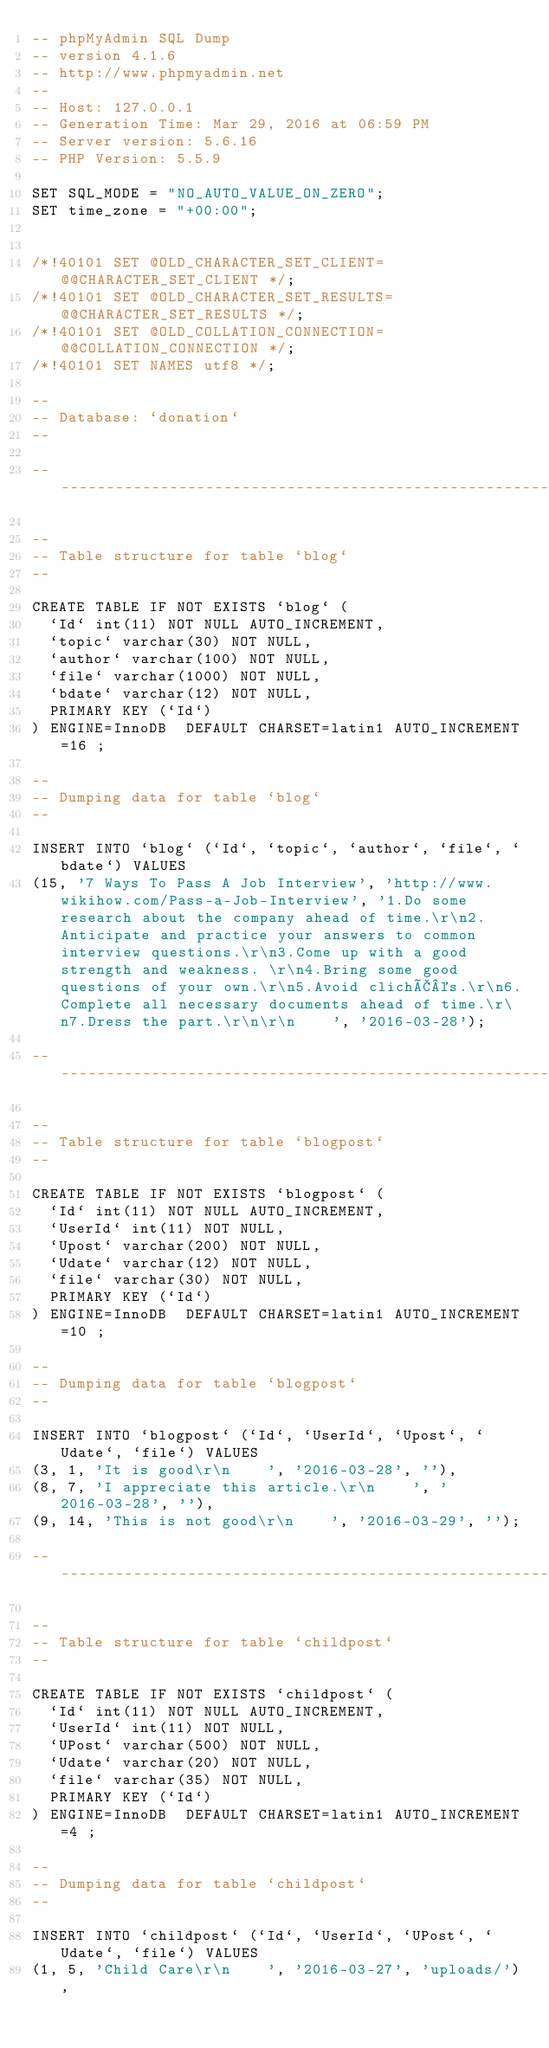<code> <loc_0><loc_0><loc_500><loc_500><_SQL_>-- phpMyAdmin SQL Dump
-- version 4.1.6
-- http://www.phpmyadmin.net
--
-- Host: 127.0.0.1
-- Generation Time: Mar 29, 2016 at 06:59 PM
-- Server version: 5.6.16
-- PHP Version: 5.5.9

SET SQL_MODE = "NO_AUTO_VALUE_ON_ZERO";
SET time_zone = "+00:00";


/*!40101 SET @OLD_CHARACTER_SET_CLIENT=@@CHARACTER_SET_CLIENT */;
/*!40101 SET @OLD_CHARACTER_SET_RESULTS=@@CHARACTER_SET_RESULTS */;
/*!40101 SET @OLD_COLLATION_CONNECTION=@@COLLATION_CONNECTION */;
/*!40101 SET NAMES utf8 */;

--
-- Database: `donation`
--

-- --------------------------------------------------------

--
-- Table structure for table `blog`
--

CREATE TABLE IF NOT EXISTS `blog` (
  `Id` int(11) NOT NULL AUTO_INCREMENT,
  `topic` varchar(30) NOT NULL,
  `author` varchar(100) NOT NULL,
  `file` varchar(1000) NOT NULL,
  `bdate` varchar(12) NOT NULL,
  PRIMARY KEY (`Id`)
) ENGINE=InnoDB  DEFAULT CHARSET=latin1 AUTO_INCREMENT=16 ;

--
-- Dumping data for table `blog`
--

INSERT INTO `blog` (`Id`, `topic`, `author`, `file`, `bdate`) VALUES
(15, '7 Ways To Pass A Job Interview', 'http://www.wikihow.com/Pass-a-Job-Interview', '1.Do some research about the company ahead of time.\r\n2.Anticipate and practice your answers to common interview questions.\r\n3.Come up with a good strength and weakness. \r\n4.Bring some good questions of your own.\r\n5.Avoid clichÃ©s.\r\n6.Complete all necessary documents ahead of time.\r\n7.Dress the part.\r\n\r\n    ', '2016-03-28');

-- --------------------------------------------------------

--
-- Table structure for table `blogpost`
--

CREATE TABLE IF NOT EXISTS `blogpost` (
  `Id` int(11) NOT NULL AUTO_INCREMENT,
  `UserId` int(11) NOT NULL,
  `Upost` varchar(200) NOT NULL,
  `Udate` varchar(12) NOT NULL,
  `file` varchar(30) NOT NULL,
  PRIMARY KEY (`Id`)
) ENGINE=InnoDB  DEFAULT CHARSET=latin1 AUTO_INCREMENT=10 ;

--
-- Dumping data for table `blogpost`
--

INSERT INTO `blogpost` (`Id`, `UserId`, `Upost`, `Udate`, `file`) VALUES
(3, 1, 'It is good\r\n    ', '2016-03-28', ''),
(8, 7, 'I appreciate this article.\r\n    ', '2016-03-28', ''),
(9, 14, 'This is not good\r\n    ', '2016-03-29', '');

-- --------------------------------------------------------

--
-- Table structure for table `childpost`
--

CREATE TABLE IF NOT EXISTS `childpost` (
  `Id` int(11) NOT NULL AUTO_INCREMENT,
  `UserId` int(11) NOT NULL,
  `UPost` varchar(500) NOT NULL,
  `Udate` varchar(20) NOT NULL,
  `file` varchar(35) NOT NULL,
  PRIMARY KEY (`Id`)
) ENGINE=InnoDB  DEFAULT CHARSET=latin1 AUTO_INCREMENT=4 ;

--
-- Dumping data for table `childpost`
--

INSERT INTO `childpost` (`Id`, `UserId`, `UPost`, `Udate`, `file`) VALUES
(1, 5, 'Child Care\r\n    ', '2016-03-27', 'uploads/'),</code> 